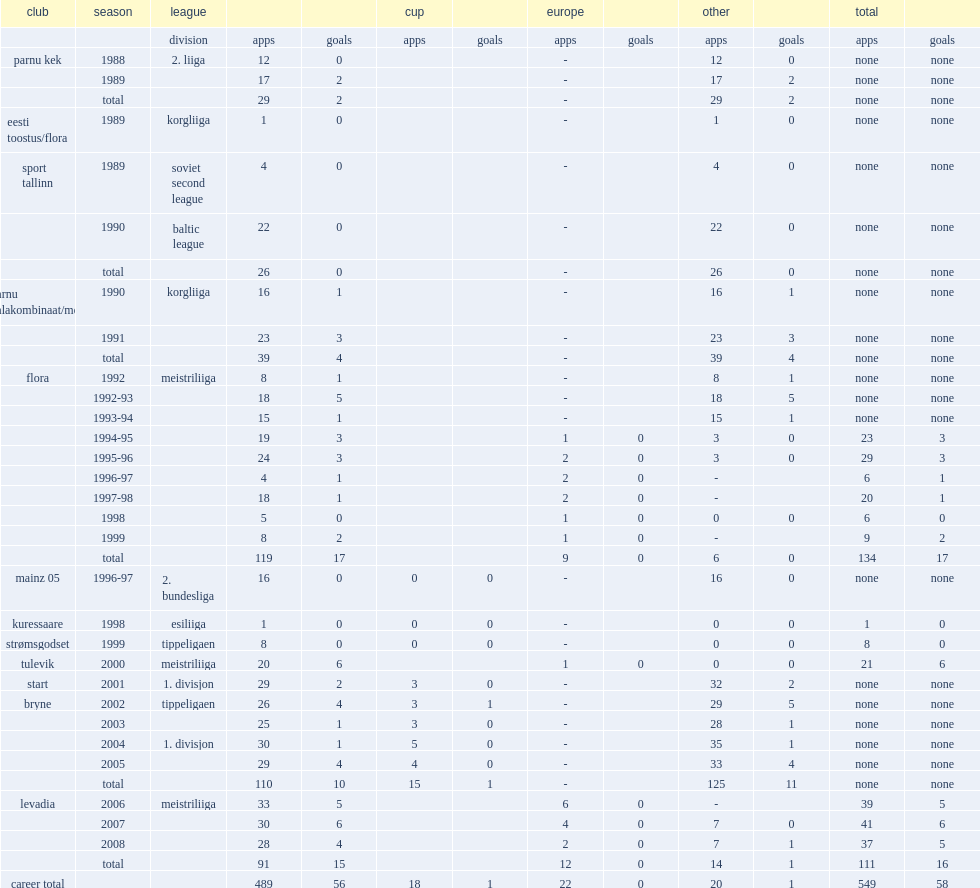In 1992, which league did lemsalu join flora for? Meistriliiga. 